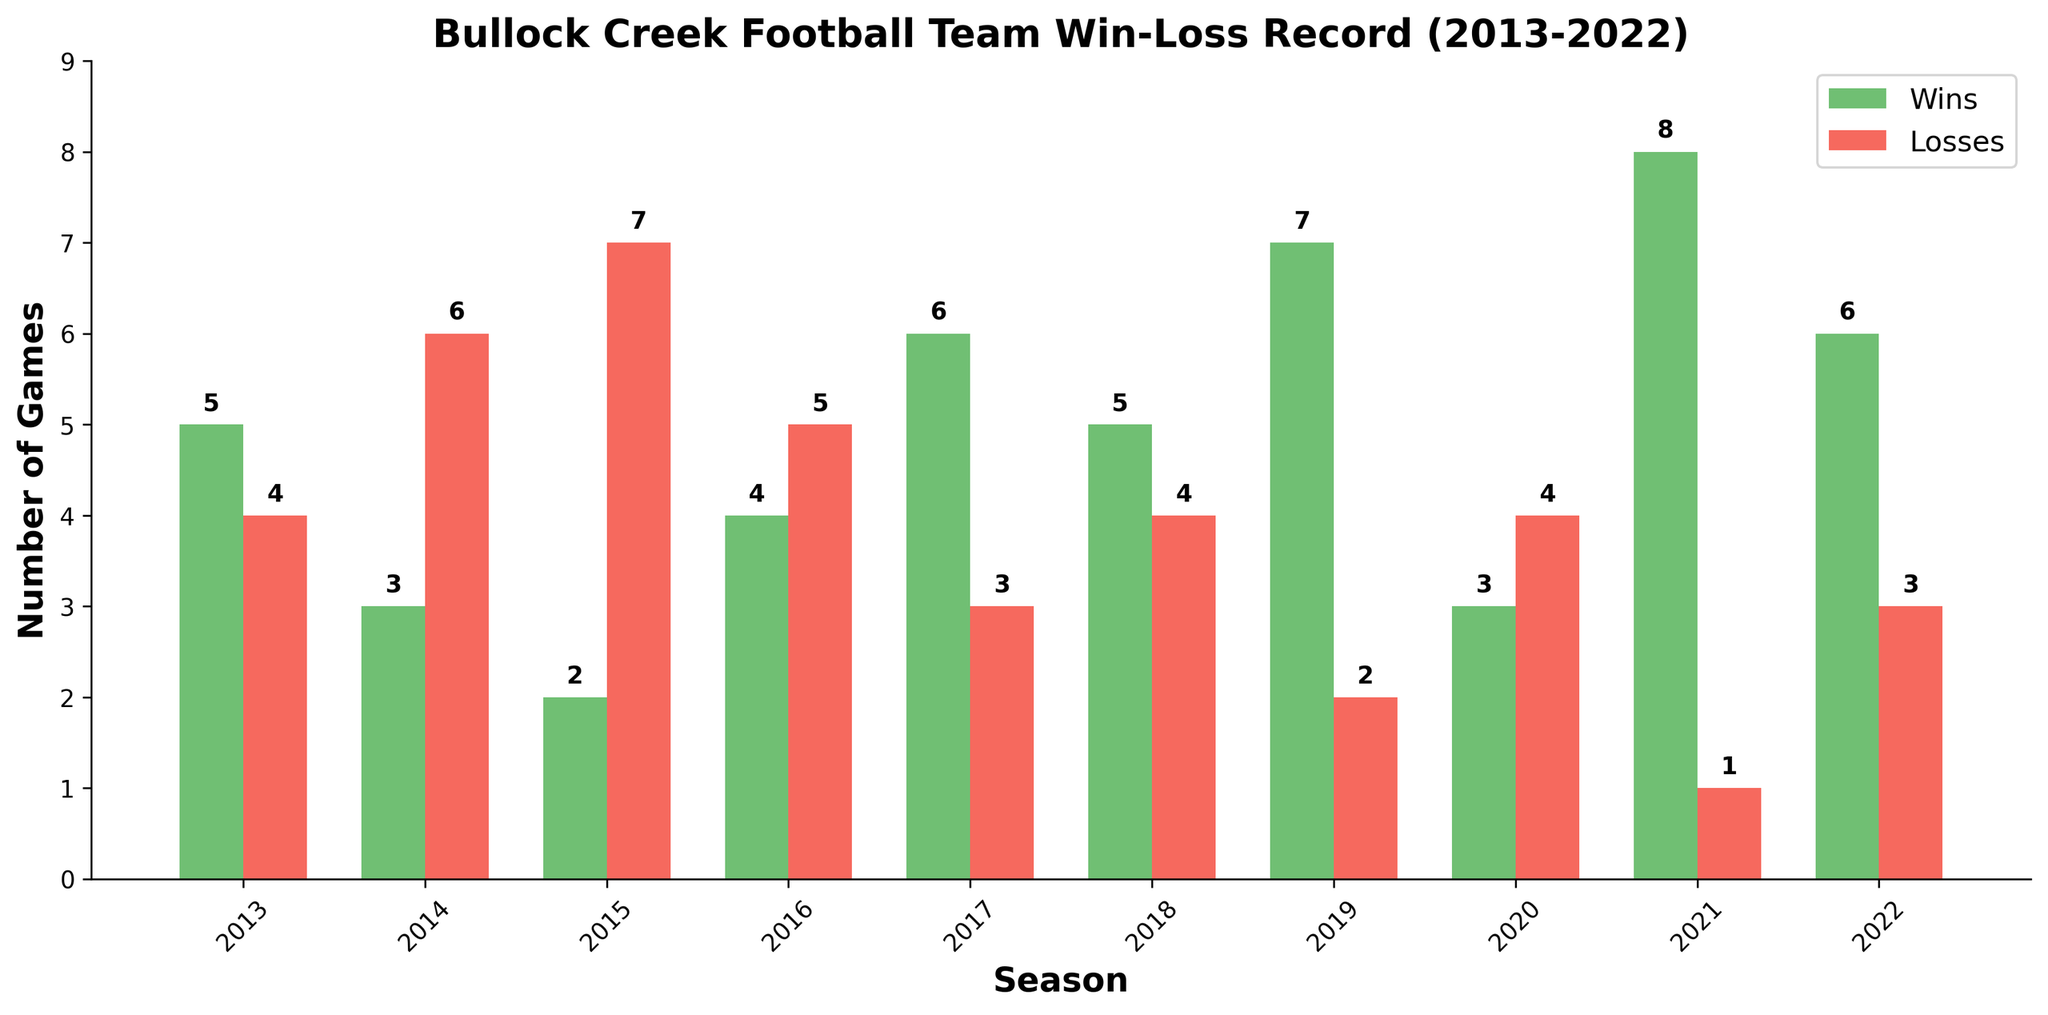Which season had the highest number of wins? Look at the "Wins" bars in the figure and identify the tallest. The 2021 season had the most wins, as its green bar is tallest.
Answer: 2021 How many total games did the Bullock Creek football team play in the 2018 season? Sum the wins and losses for 2018. The 2018 season shows 5 wins and 4 losses. Adding these gives 5 + 4 = 9.
Answer: 9 Which season had the lowest number of losses? Look at the "Losses" bars in the figure and identify the shortest. The 2021 season had the fewest losses, with just 1 loss.
Answer: 2021 How many more wins were there in 2021 compared to 2014? Subtract the wins in 2014 from the wins in 2021. In 2021, there are 8 wins, and in 2014, there are 3 wins. The difference is 8 - 3 = 5.
Answer: 5 Which seasons had an equal number of wins and losses? Identify seasons where the "Wins" bar height is equal to the "Losses" bar height. No season in the chart shows an equal number of wins and losses.
Answer: None How many total wins did the team achieve over the 10 seasons? Sum the number of wins from each season from 2013 to 2022. The total is 5 + 3 + 2 + 4 + 6 + 5 + 7 + 3 + 8 + 6 = 49.
Answer: 49 In which seasons did the team have more losses than wins? Identify seasons where the "Losses" bar is taller than the "Wins" bar. The seasons are 2014, 2015, 2016, and 2020.
Answer: 2014, 2015, 2016, 2020 What's the average number of wins per season? Calculate the average by summing the wins across all seasons and dividing by the number of seasons. Sum of wins is 49, number of seasons is 10, so the average is 49 / 10 = 4.9.
Answer: 4.9 